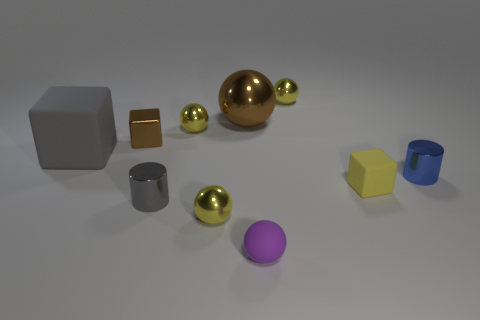Subtract all tiny matte spheres. How many spheres are left? 4 Subtract all cyan cylinders. How many yellow balls are left? 3 Subtract all purple spheres. How many spheres are left? 4 Subtract all cubes. How many objects are left? 7 Subtract 1 balls. How many balls are left? 4 Add 9 cyan matte blocks. How many cyan matte blocks exist? 9 Subtract 0 green cylinders. How many objects are left? 10 Subtract all purple balls. Subtract all green cylinders. How many balls are left? 4 Subtract all tiny metallic cylinders. Subtract all large gray objects. How many objects are left? 7 Add 1 small purple matte spheres. How many small purple matte spheres are left? 2 